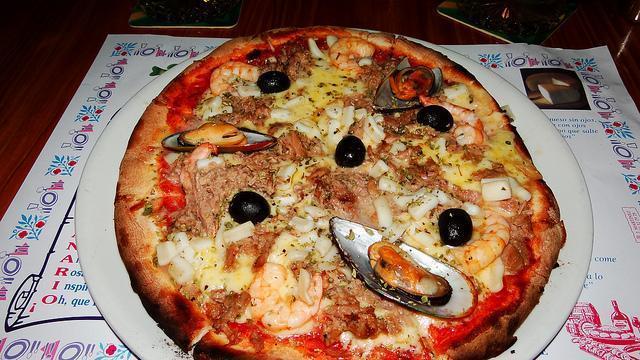How many people are in dresses?
Give a very brief answer. 0. 